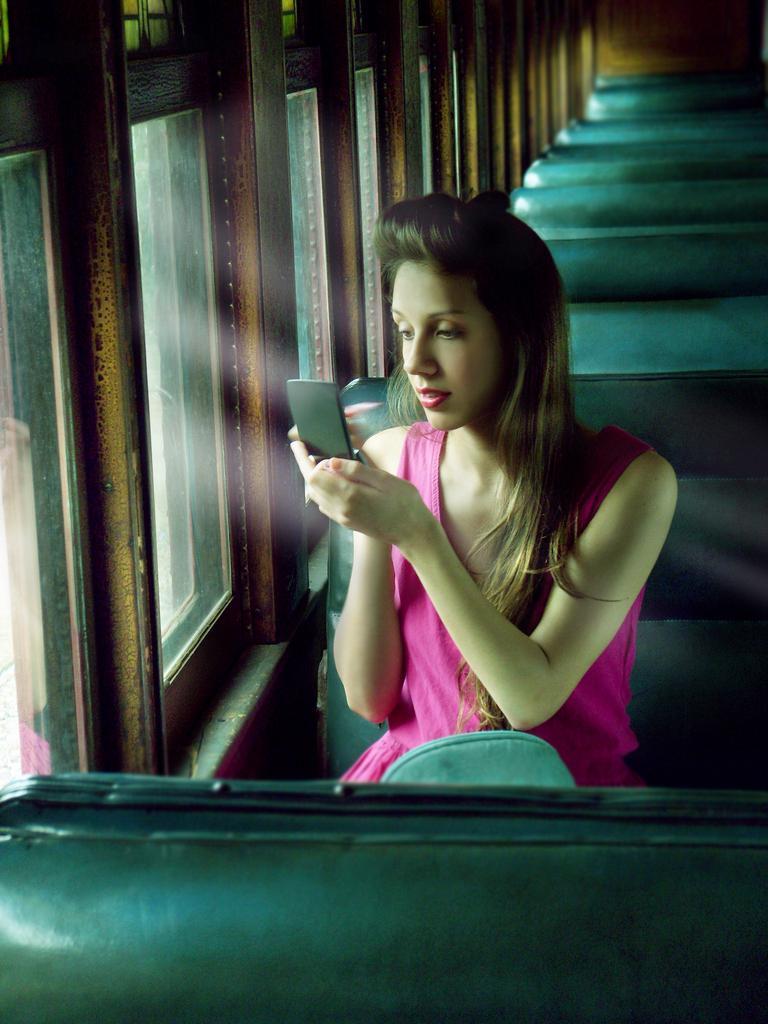Could you give a brief overview of what you see in this image? In this image I can see a woman wearing pink colored dress is sitting on a bench which is green in color and holding a black colored object in hand. I can see few windows and few benches which are green in color. 